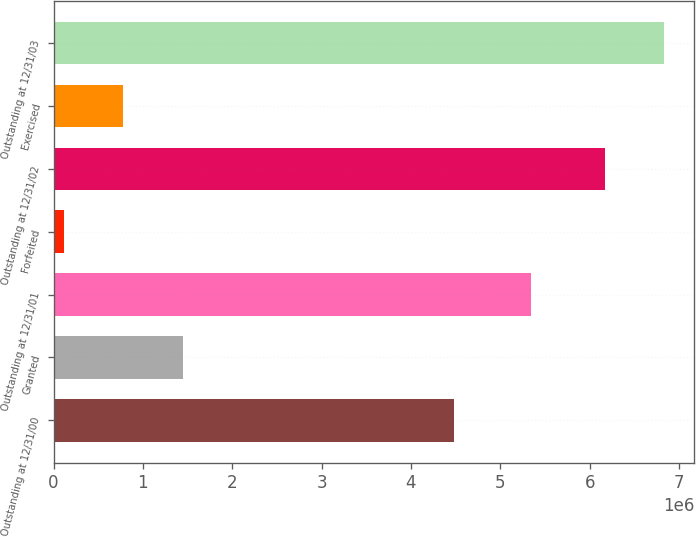Convert chart. <chart><loc_0><loc_0><loc_500><loc_500><bar_chart><fcel>Outstanding at 12/31/00<fcel>Granted<fcel>Outstanding at 12/31/01<fcel>Forfeited<fcel>Outstanding at 12/31/02<fcel>Exercised<fcel>Outstanding at 12/31/03<nl><fcel>4.48511e+06<fcel>1.44425e+06<fcel>5.34645e+06<fcel>116950<fcel>6.16615e+06<fcel>780598<fcel>6.8298e+06<nl></chart> 